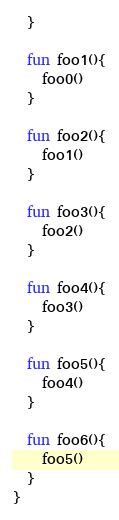<code> <loc_0><loc_0><loc_500><loc_500><_Kotlin_>  }

  fun foo1(){
    foo0()
  }

  fun foo2(){
    foo1()
  }

  fun foo3(){
    foo2()
  }

  fun foo4(){
    foo3()
  }

  fun foo5(){
    foo4()
  }

  fun foo6(){
    foo5()
  }
}</code> 